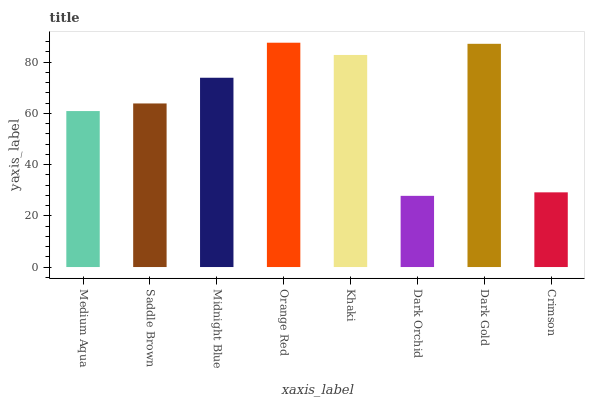Is Dark Orchid the minimum?
Answer yes or no. Yes. Is Orange Red the maximum?
Answer yes or no. Yes. Is Saddle Brown the minimum?
Answer yes or no. No. Is Saddle Brown the maximum?
Answer yes or no. No. Is Saddle Brown greater than Medium Aqua?
Answer yes or no. Yes. Is Medium Aqua less than Saddle Brown?
Answer yes or no. Yes. Is Medium Aqua greater than Saddle Brown?
Answer yes or no. No. Is Saddle Brown less than Medium Aqua?
Answer yes or no. No. Is Midnight Blue the high median?
Answer yes or no. Yes. Is Saddle Brown the low median?
Answer yes or no. Yes. Is Orange Red the high median?
Answer yes or no. No. Is Medium Aqua the low median?
Answer yes or no. No. 